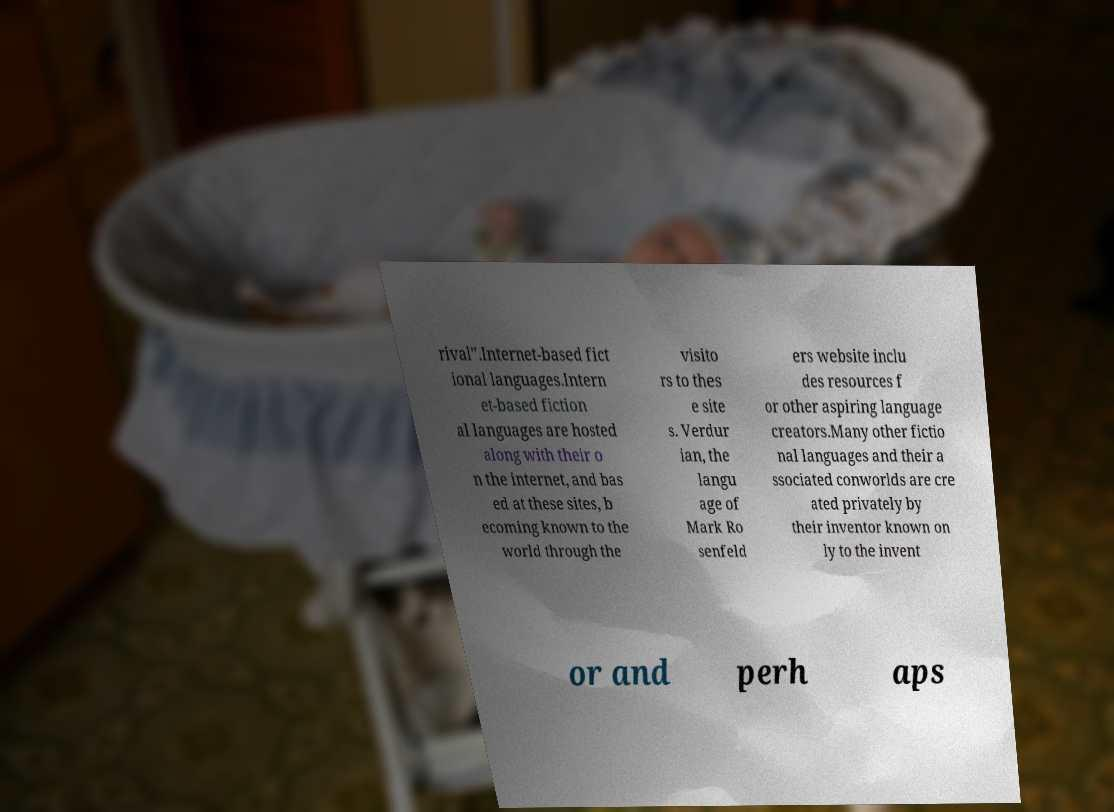Could you extract and type out the text from this image? rival".Internet-based fict ional languages.Intern et-based fiction al languages are hosted along with their o n the internet, and bas ed at these sites, b ecoming known to the world through the visito rs to thes e site s. Verdur ian, the langu age of Mark Ro senfeld ers website inclu des resources f or other aspiring language creators.Many other fictio nal languages and their a ssociated conworlds are cre ated privately by their inventor known on ly to the invent or and perh aps 